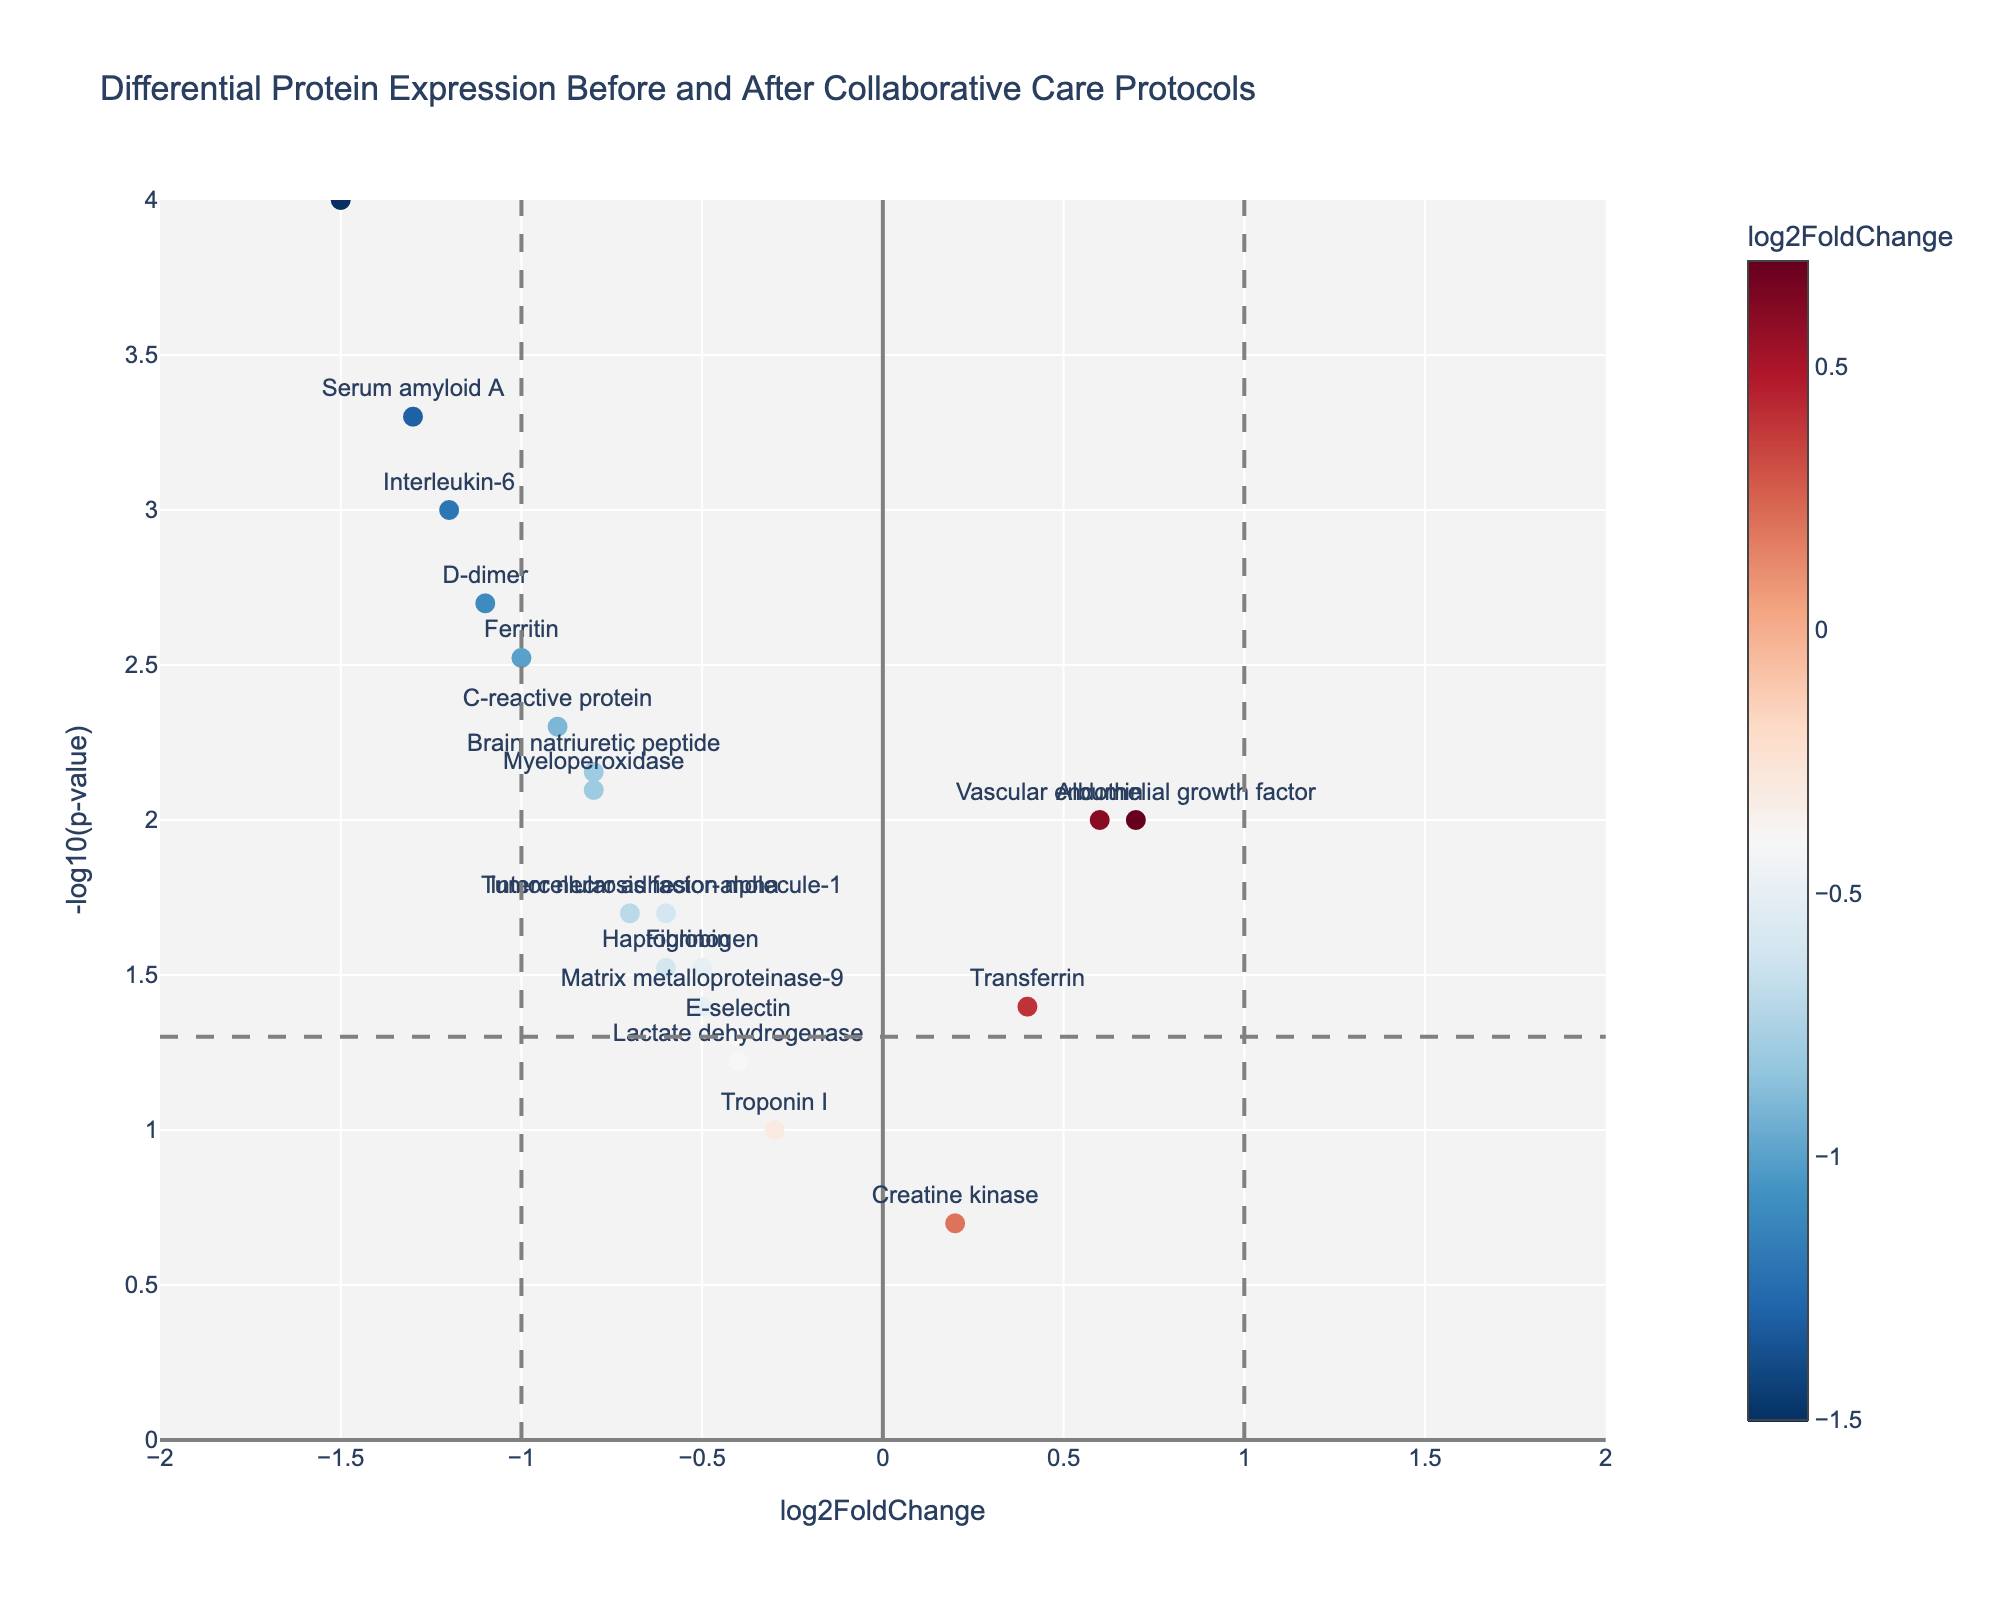How many proteins have a log2FoldChange greater than 0? By counting the data points on the right side of the y-axis (log2FoldChange > 0), you can see the proteins with a positive value.
Answer: 4 What is the significance threshold for the p-value in this plot? The horizontal line set at y = -log10(0.05) indicates the threshold of significance for the p-value.
Answer: 0.05 Which protein has the highest log2FoldChange value? By identifying the point on the plot farthest to the right on the x-axis, we can determine which protein has the highest log2FoldChange.
Answer: Vascular endothelial growth factor How many proteins have a p-value less than 0.01? Points above the y = 2 line on the plot correspond to proteins with a p-value < 0.01; counting these points gives the answer.
Answer: 6 What color scale is used to represent log2FoldChange values on the plot? Observing the color bar on the right side of the plot shows the color scale, from blue for negative values to red for positive values.
Answer: RdBu_r How many proteins have both a negative log2FoldChange and a p-value < 0.05? Locate the points in the left part of the plot (log2FoldChange < 0) and above the y = 1.3 line (p-value < 0.05) to find the count.
Answer: 11 Among the proteins with statistically significant changes, which one has the most negative log2FoldChange value? Identify the lowest (leftmost) point among those above the y = 1.3 line and check its corresponding protein.
Answer: Procalcitonin What does the vertical line at log2FoldChange = -1 signify? The vertical line at x = -1 indicates a specific threshold of interest for log2FoldChange values.
Answer: Threshold at -1 log2FoldChange Compare the p-values of Serum amyloid A and D-dimer. Which one is more significant? Serum amyloid A's point is higher on the y-axis than D-dimer's, indicating a lower p-value and thus more significance.
Answer: Serum amyloid A Which protein has a significant increase in its expression after the implementation of collaborative care protocols? Look for proteins in the right part of the plot (log2FoldChange > 0) and above y = 1.3.
Answer: Albumin and Vascular endothelial growth factor 